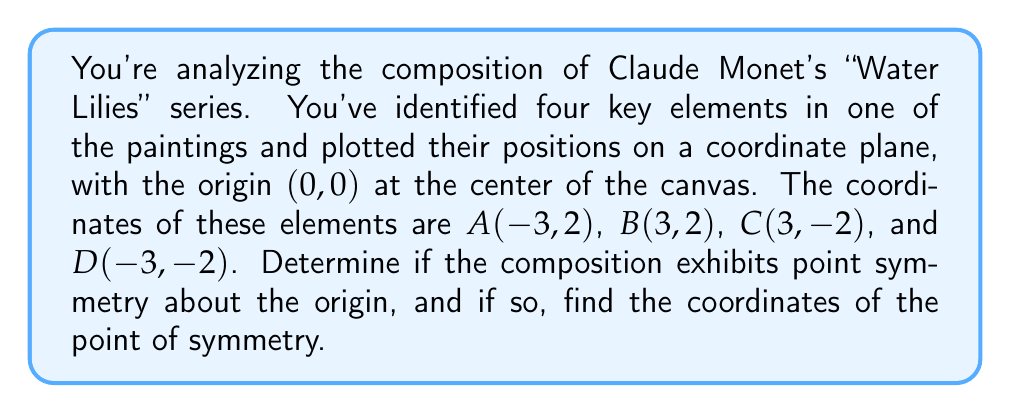What is the answer to this math problem? To determine if the composition has point symmetry about the origin, we need to check if each point has a corresponding point that is equidistant from the origin but in the opposite direction.

1. First, let's examine the coordinates of each point:
   A(-3,2), B(3,2), C(3,-2), D(-3,-2)

2. For point symmetry about the origin, each point (x,y) should have a corresponding point (-x,-y).

3. Let's check each pair:
   - A(-3,2) corresponds to C(3,-2)
   - B(3,2) corresponds to D(-3,-2)

4. We can verify this mathematically:
   - For A and C: $(-3,2) \rightarrow (3,-2)$
     The x-coordinate changes from -3 to 3 (opposite sign)
     The y-coordinate changes from 2 to -2 (opposite sign)
   - For B and D: $(3,2) \rightarrow (-3,-2)$
     The x-coordinate changes from 3 to -3 (opposite sign)
     The y-coordinate changes from 2 to -2 (opposite sign)

5. Since each point has a corresponding point that is equidistant from the origin but in the opposite direction, the composition exhibits point symmetry.

6. The point of symmetry is the point around which this symmetry occurs. In the case of point symmetry about the origin, the point of symmetry is always the origin itself (0,0).

[asy]
unitsize(1cm);
draw((-4,-3)--(4,-3)--(4,3)--(-4,3)--cycle);
dot((-3,2));
dot((3,2));
dot((3,-2));
dot((-3,-2));
dot((0,0));
label("A", (-3,2), NW);
label("B", (3,2), NE);
label("C", (3,-2), SE);
label("D", (-3,-2), SW);
label("O", (0,0), S);
draw((-4,0)--(4,0),dashed);
draw((0,-3)--(0,3),dashed);
[/asy]
Answer: Yes, the composition exhibits point symmetry about the origin. The point of symmetry is (0,0). 